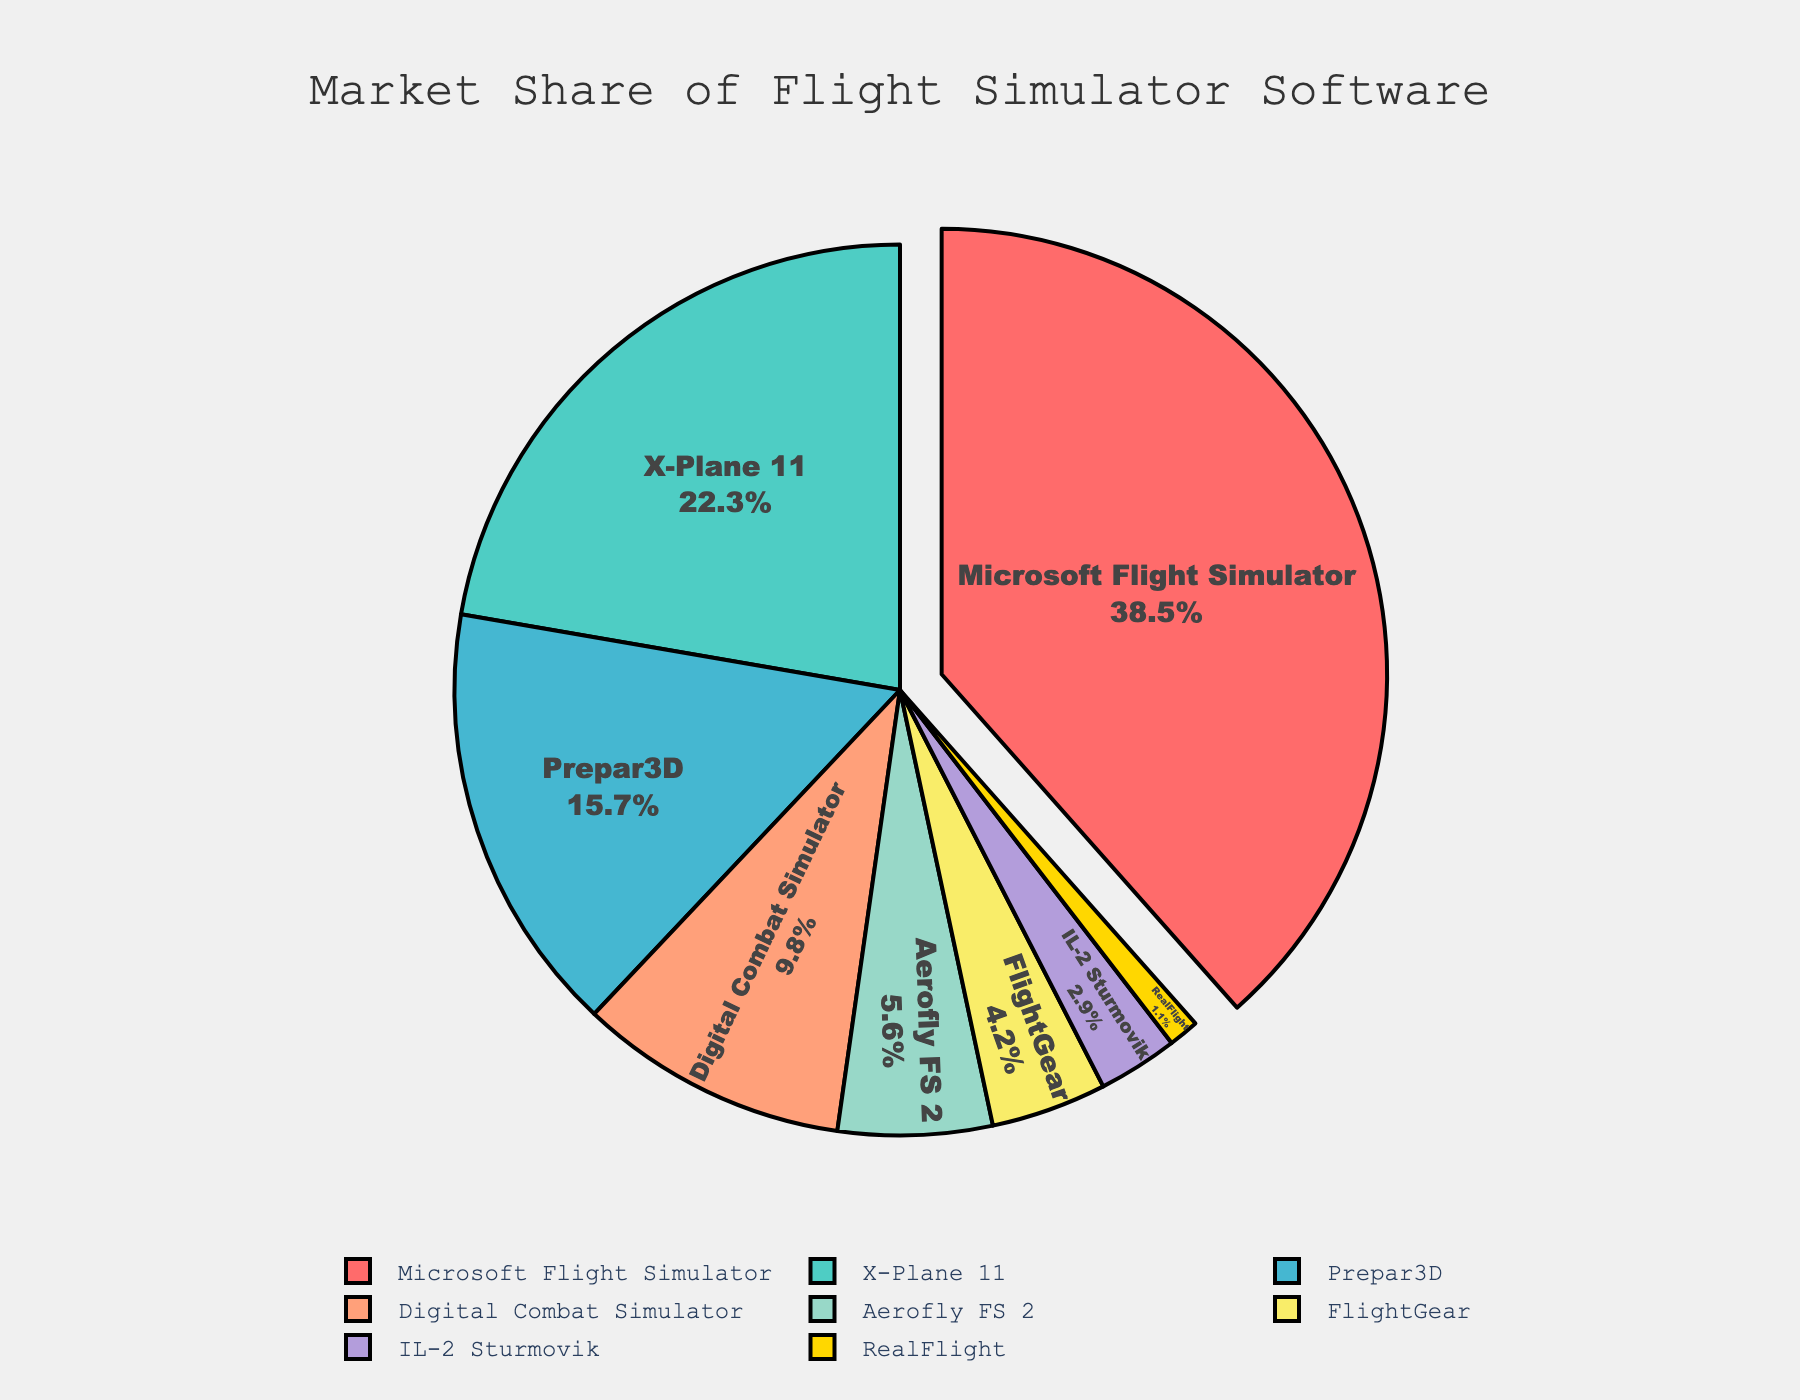What is the market share of Microsoft Flight Simulator? The figure shows a pie chart with various sections representing different flight simulator software, with their market shares indicated. The slice for Microsoft Flight Simulator is highlighted and displays a value of 38.5%.
Answer: 38.5% Which flight simulator software has the least market share? By looking at the pie chart, we can identify the smallest slice, which is labeled "RealFlight" with a market share of 1.1%.
Answer: RealFlight How much more market share does X-Plane 11 have compared to FlightGear? The pie chart gives the market share for X-Plane 11 as 22.3% and for FlightGear as 4.2%. Calculating the difference: 22.3% - 4.2% = 18.1%.
Answer: 18.1% What is the combined market share of Digital Combat Simulator and IL-2 Sturmovik? According to the pie chart, Digital Combat Simulator has a market share of 9.8% and IL-2 Sturmovik has 2.9%. Summing these values: 9.8% + 2.9% = 12.7%.
Answer: 12.7% Arrange the software platforms in descending order of their market share. By examining the pie chart, the software platforms and their respective market shares are: Microsoft Flight Simulator (38.5%), X-Plane 11 (22.3%), Prepar3D (15.7%), Digital Combat Simulator (9.8%), Aerofly FS 2 (5.6%), FlightGear (4.2%), IL-2 Sturmovik (2.9%), RealFlight (1.1%). Arranging them in descending order: Microsoft Flight Simulator, X-Plane 11, Prepar3D, Digital Combat Simulator, Aerofly FS 2, FlightGear, IL-2 Sturmovik, RealFlight.
Answer: Microsoft Flight Simulator, X-Plane 11, Prepar3D, Digital Combat Simulator, Aerofly FS 2, FlightGear, IL-2 Sturmovik, RealFlight Which software has the second-largest market share? By inspecting the pie chart, the slice with the second-largest market share is for X-Plane 11 with 22.3%.
Answer: X-Plane 11 If the market share of Prepar3D and Aerofly FS 2 were combined, would their total exceed that of X-Plane 11? From the chart, Prepar3D has a market share of 15.7% and Aerofly FS 2 has 5.6%. Adding these values: 15.7% + 5.6% = 21.3%, which is less than X-Plane 11's 22.3%.
Answer: No What percentage of the market do the top three software platforms cover? The top three software platforms are Microsoft Flight Simulator (38.5%), X-Plane 11 (22.3%), and Prepar3D (15.7%). Summing these values: 38.5% + 22.3% + 15.7% = 76.5%.
Answer: 76.5% What is the market share difference between Aerofly FS 2 and IL-2 Sturmovik? The pie chart shows Aerofly FS 2 with a market share of 5.6% and IL-2 Sturmovik with 2.9%. Calculating the difference: 5.6% - 2.9% = 2.7%.
Answer: 2.7% 